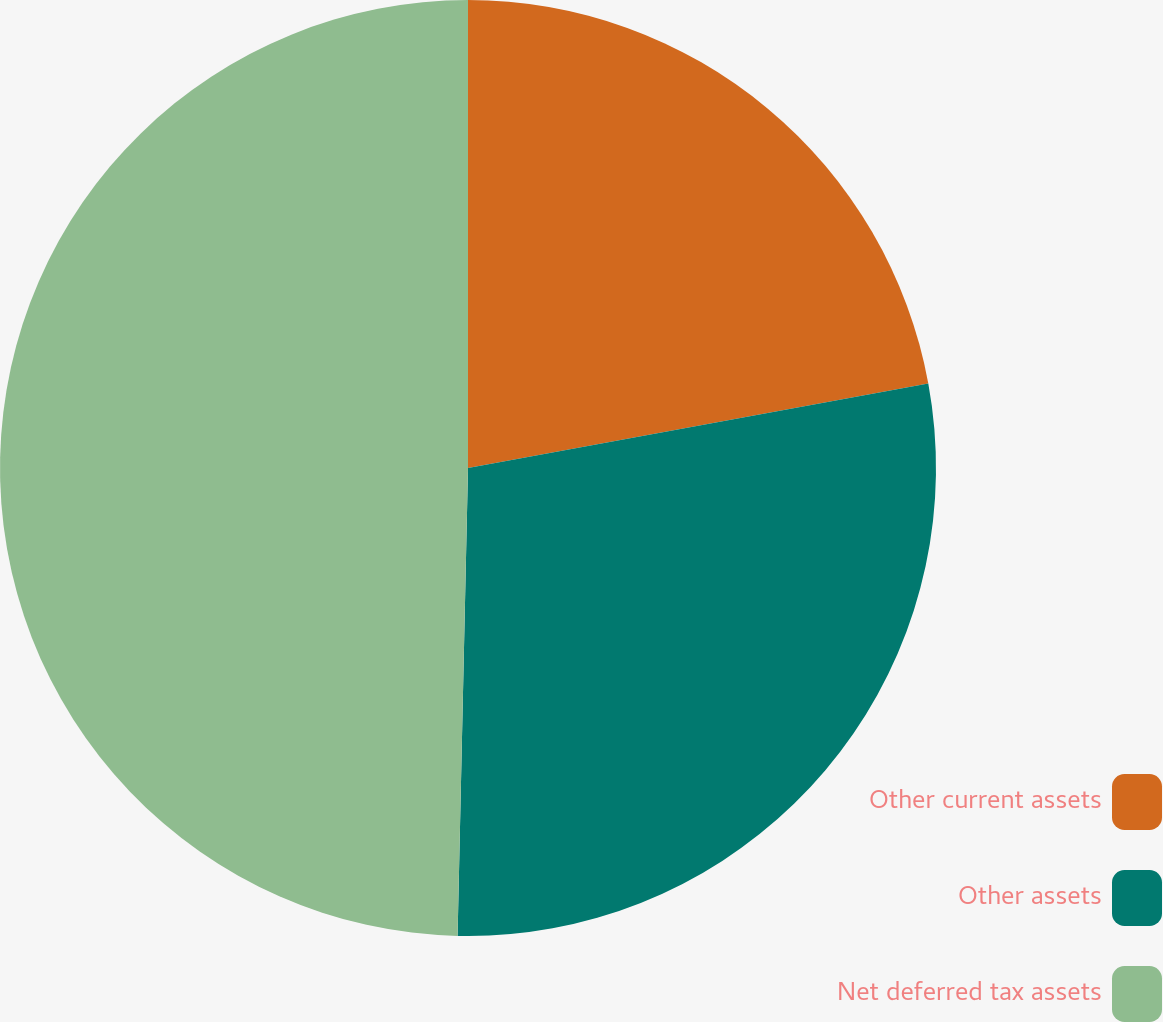<chart> <loc_0><loc_0><loc_500><loc_500><pie_chart><fcel>Other current assets<fcel>Other assets<fcel>Net deferred tax assets<nl><fcel>22.11%<fcel>28.25%<fcel>49.65%<nl></chart> 